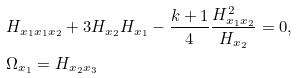<formula> <loc_0><loc_0><loc_500><loc_500>& H _ { x _ { 1 } x _ { 1 } x _ { 2 } } + 3 H _ { x _ { 2 } } H _ { x _ { 1 } } - \frac { k + 1 } { 4 } \frac { H _ { x _ { 1 } x _ { 2 } } ^ { 2 } } { H _ { x _ { 2 } } } = 0 , \\ & \Omega _ { x _ { 1 } } = H _ { x _ { 2 } x _ { 3 } }</formula> 